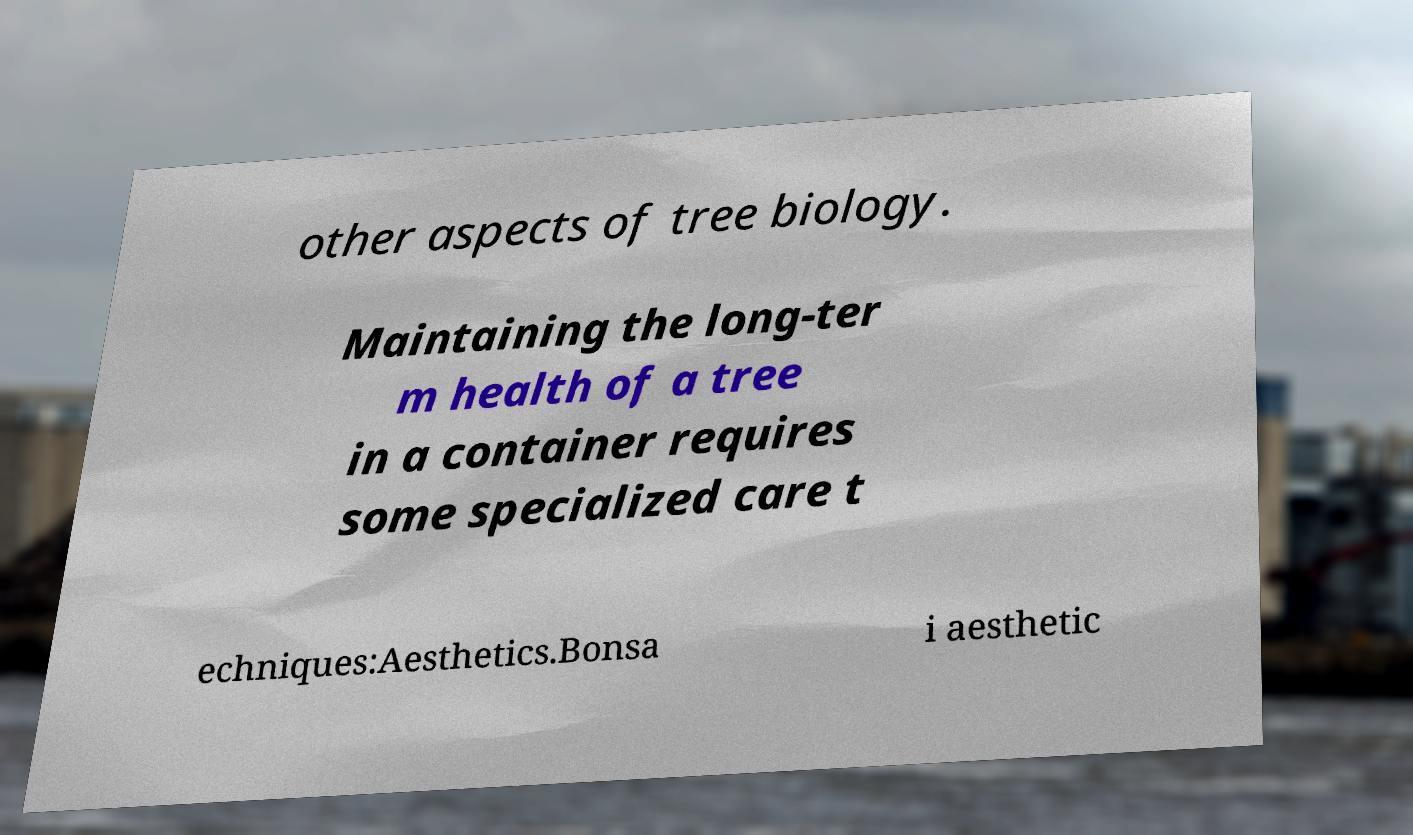Can you accurately transcribe the text from the provided image for me? other aspects of tree biology. Maintaining the long-ter m health of a tree in a container requires some specialized care t echniques:Aesthetics.Bonsa i aesthetic 